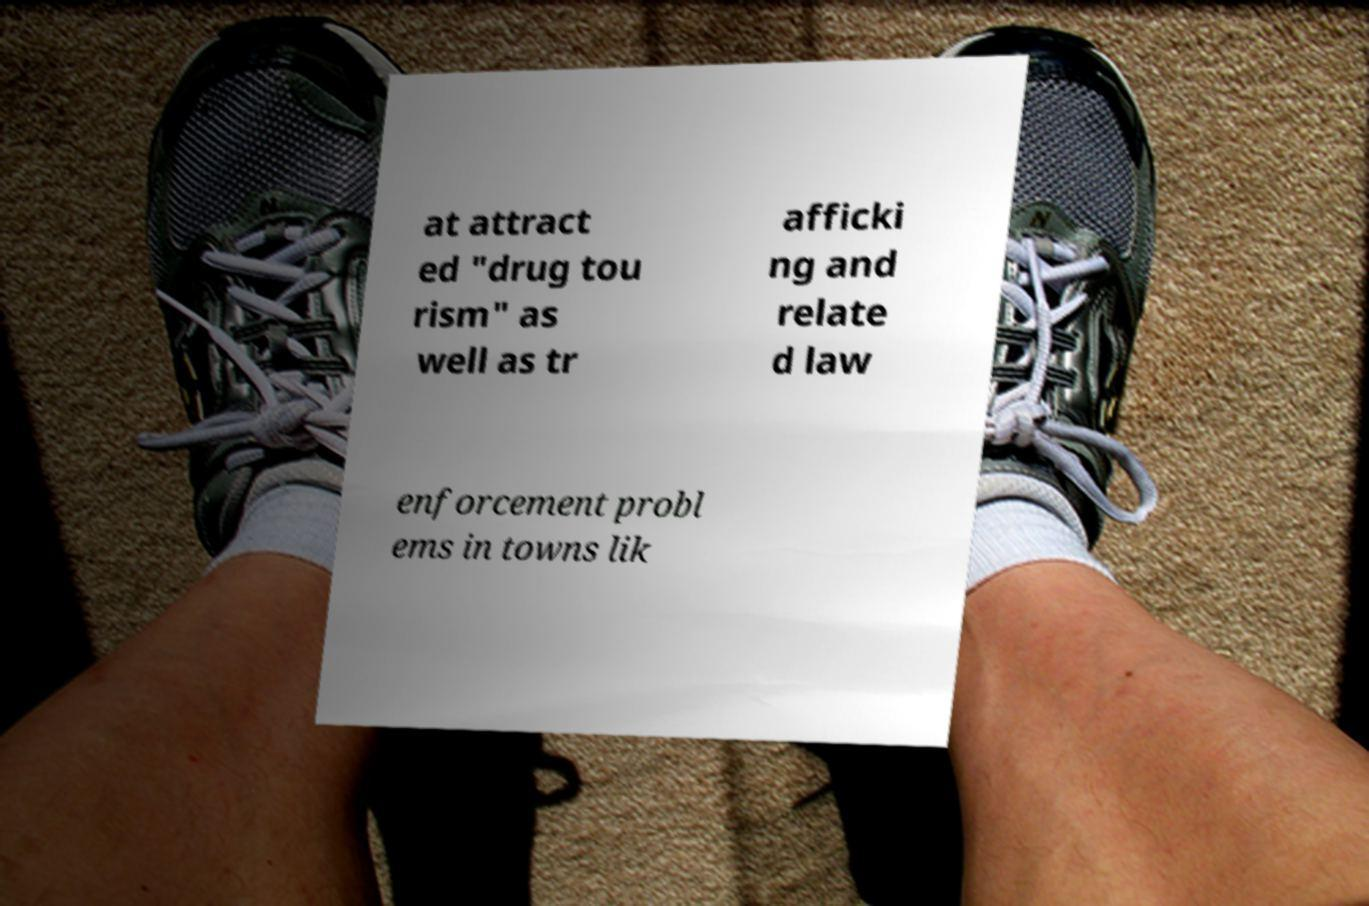There's text embedded in this image that I need extracted. Can you transcribe it verbatim? at attract ed "drug tou rism" as well as tr afficki ng and relate d law enforcement probl ems in towns lik 